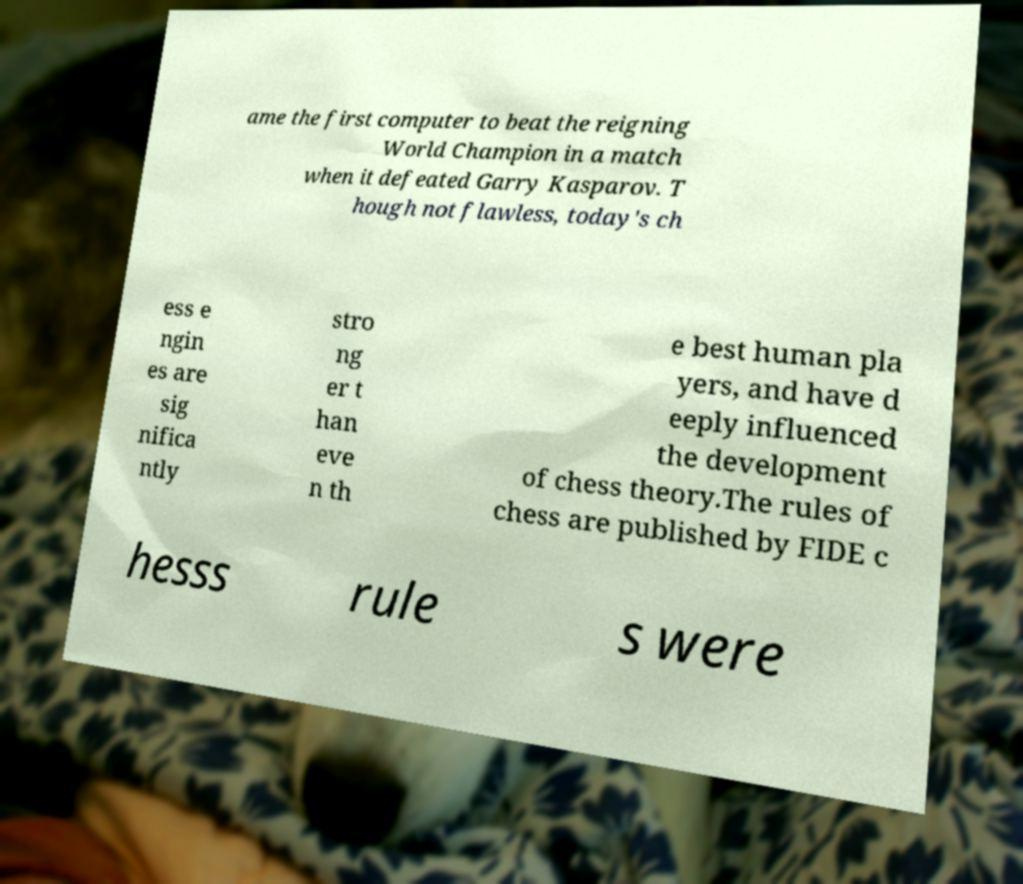Could you assist in decoding the text presented in this image and type it out clearly? ame the first computer to beat the reigning World Champion in a match when it defeated Garry Kasparov. T hough not flawless, today's ch ess e ngin es are sig nifica ntly stro ng er t han eve n th e best human pla yers, and have d eeply influenced the development of chess theory.The rules of chess are published by FIDE c hesss rule s were 